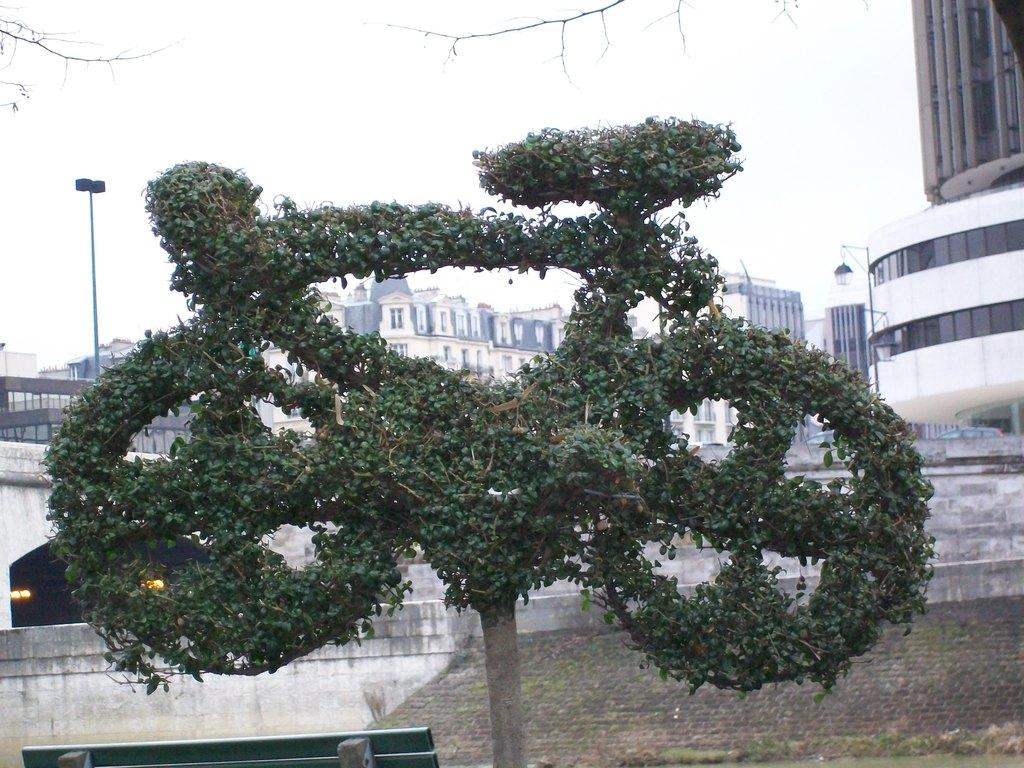What is the main subject of the image? The main subject of the image is a sculpture covered with grass. What else can be seen in the image besides the sculpture? There are buildings and poles in the image. What is visible in the background of the image? The sky is visible in the image. What type of vase is being used for teaching in the image? There is no vase or teaching activity present in the image. What kind of vessel is being used to transport water in the image? There is no vessel or water transportation activity present in the image. 